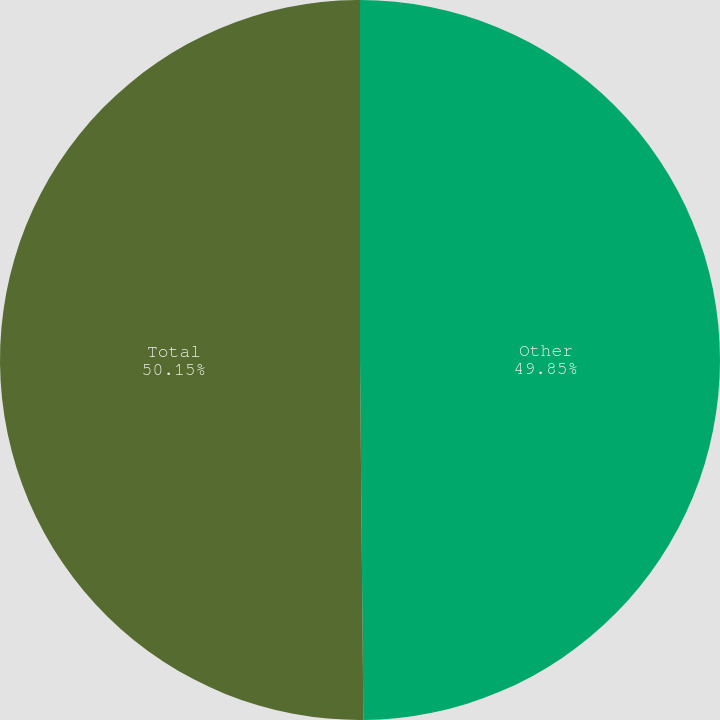Convert chart to OTSL. <chart><loc_0><loc_0><loc_500><loc_500><pie_chart><fcel>Other<fcel>Total<nl><fcel>49.85%<fcel>50.15%<nl></chart> 